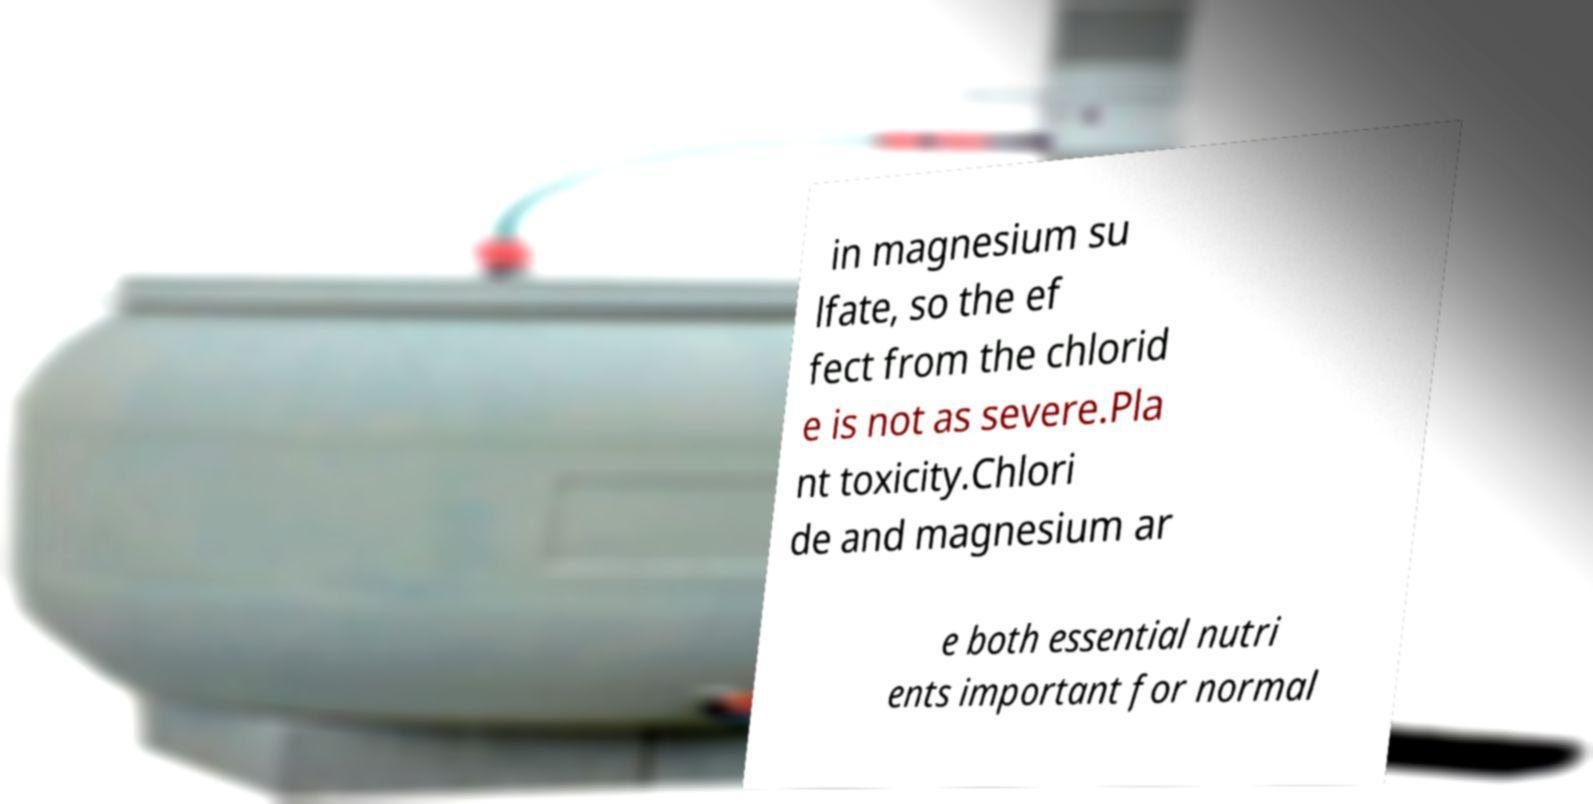I need the written content from this picture converted into text. Can you do that? in magnesium su lfate, so the ef fect from the chlorid e is not as severe.Pla nt toxicity.Chlori de and magnesium ar e both essential nutri ents important for normal 